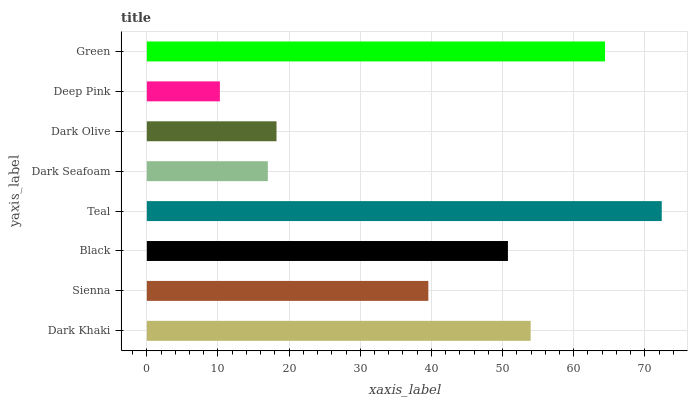Is Deep Pink the minimum?
Answer yes or no. Yes. Is Teal the maximum?
Answer yes or no. Yes. Is Sienna the minimum?
Answer yes or no. No. Is Sienna the maximum?
Answer yes or no. No. Is Dark Khaki greater than Sienna?
Answer yes or no. Yes. Is Sienna less than Dark Khaki?
Answer yes or no. Yes. Is Sienna greater than Dark Khaki?
Answer yes or no. No. Is Dark Khaki less than Sienna?
Answer yes or no. No. Is Black the high median?
Answer yes or no. Yes. Is Sienna the low median?
Answer yes or no. Yes. Is Dark Seafoam the high median?
Answer yes or no. No. Is Green the low median?
Answer yes or no. No. 